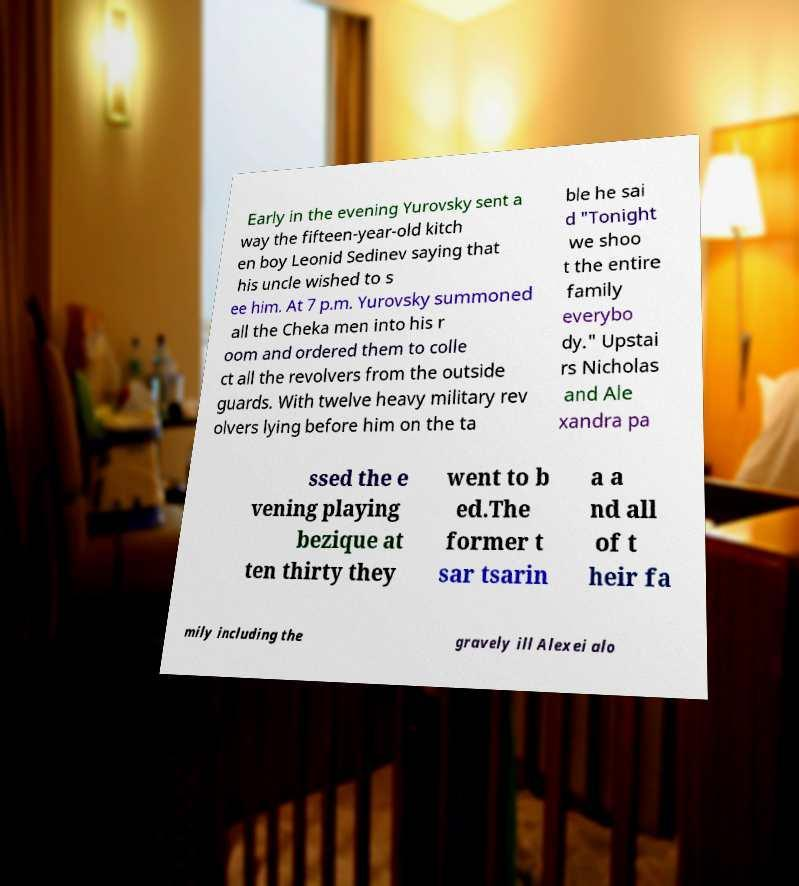Can you read and provide the text displayed in the image?This photo seems to have some interesting text. Can you extract and type it out for me? Early in the evening Yurovsky sent a way the fifteen-year-old kitch en boy Leonid Sedinev saying that his uncle wished to s ee him. At 7 p.m. Yurovsky summoned all the Cheka men into his r oom and ordered them to colle ct all the revolvers from the outside guards. With twelve heavy military rev olvers lying before him on the ta ble he sai d "Tonight we shoo t the entire family everybo dy." Upstai rs Nicholas and Ale xandra pa ssed the e vening playing bezique at ten thirty they went to b ed.The former t sar tsarin a a nd all of t heir fa mily including the gravely ill Alexei alo 